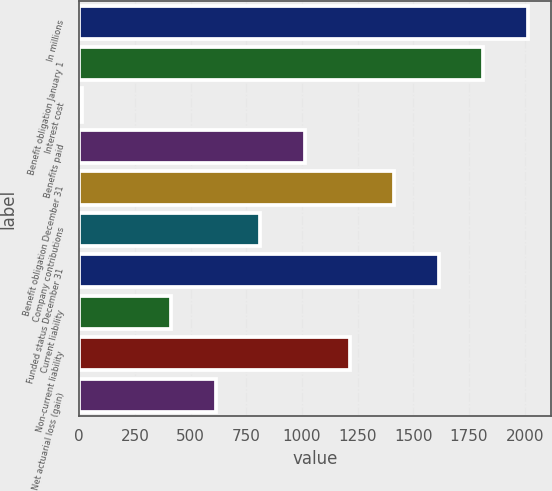Convert chart to OTSL. <chart><loc_0><loc_0><loc_500><loc_500><bar_chart><fcel>In millions<fcel>Benefit obligation January 1<fcel>Interest cost<fcel>Benefits paid<fcel>Benefit obligation December 31<fcel>Company contributions<fcel>Funded status December 31<fcel>Current liability<fcel>Non-current liability<fcel>Net actuarial loss (gain)<nl><fcel>2015<fcel>1814.6<fcel>11<fcel>1013<fcel>1413.8<fcel>812.6<fcel>1614.2<fcel>411.8<fcel>1213.4<fcel>612.2<nl></chart> 